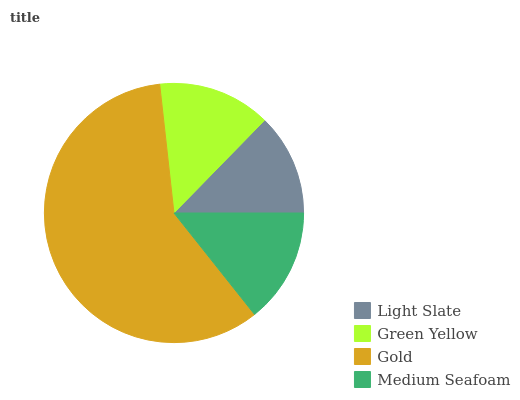Is Light Slate the minimum?
Answer yes or no. Yes. Is Gold the maximum?
Answer yes or no. Yes. Is Green Yellow the minimum?
Answer yes or no. No. Is Green Yellow the maximum?
Answer yes or no. No. Is Green Yellow greater than Light Slate?
Answer yes or no. Yes. Is Light Slate less than Green Yellow?
Answer yes or no. Yes. Is Light Slate greater than Green Yellow?
Answer yes or no. No. Is Green Yellow less than Light Slate?
Answer yes or no. No. Is Medium Seafoam the high median?
Answer yes or no. Yes. Is Green Yellow the low median?
Answer yes or no. Yes. Is Light Slate the high median?
Answer yes or no. No. Is Medium Seafoam the low median?
Answer yes or no. No. 